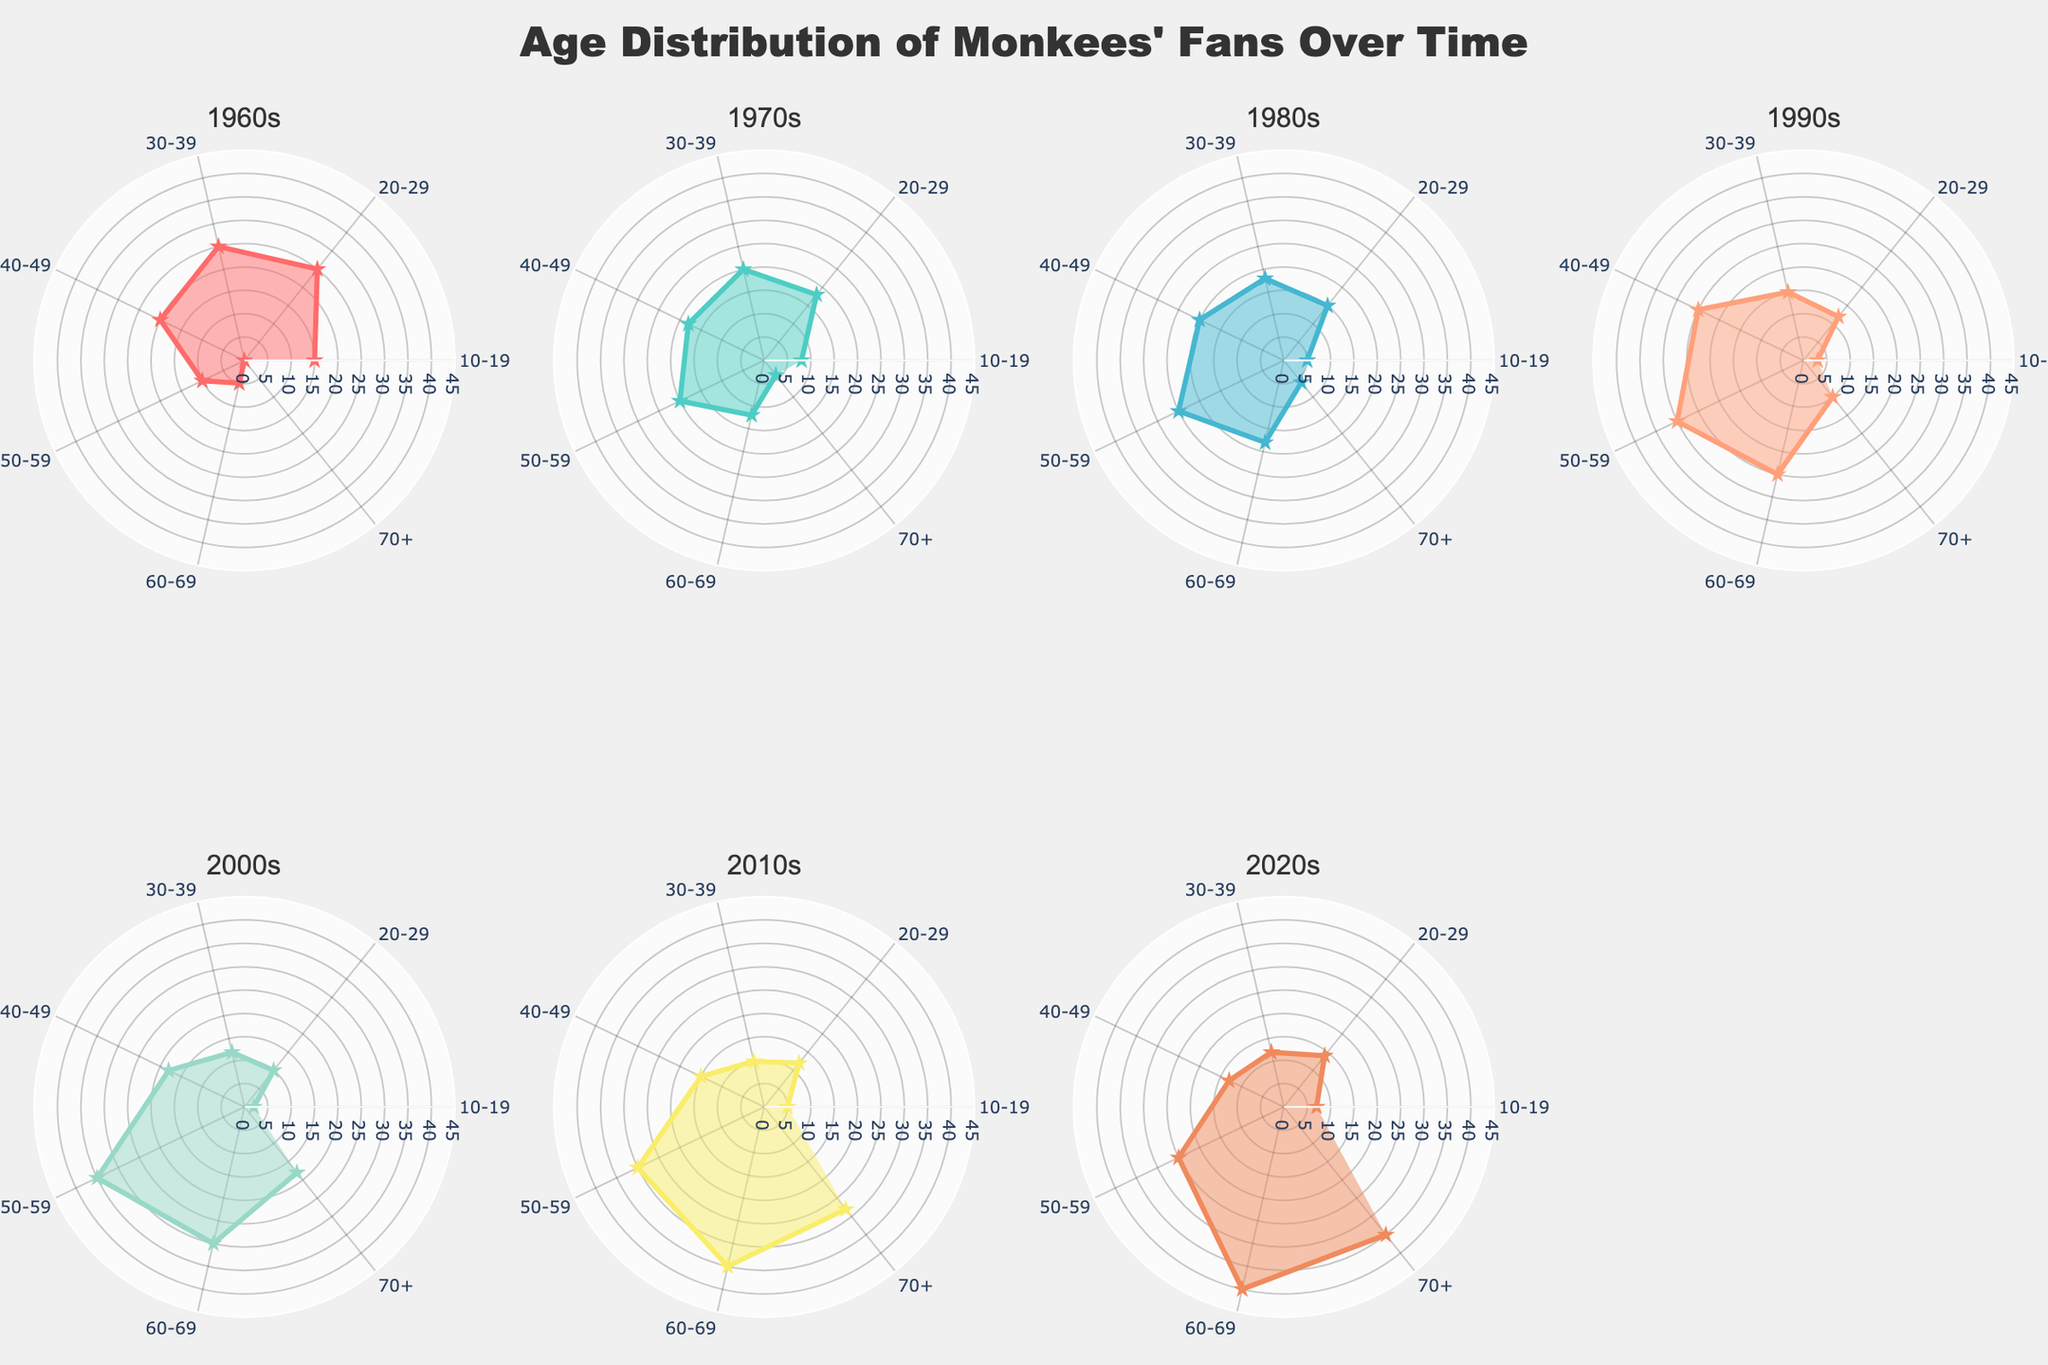What is the title of the figure? The title of the figure is typically found at the top and is prominently displayed to describe the overall content. In this case, it is clearly marked in the figure itself.
Answer: Age Distribution of Monkees' Fans Over Time What is the range of values on the radial axis? Observing the radial axis of the radar charts, the range extends from the minimum to the maximum value indicated. Here, it is visibly marked to show the range.
Answer: 0 to 45 Which age group had the highest percentage of fans in the 2020s? To find this, look at the radar plot for the 2020s and observe which age group corresponds to the longest radius. The measurements show that the age group with the highest value is near the edge of the plot.
Answer: 60-69 Which decade had the largest percentage of fans in the 50-59 age group? Locate the radial line corresponding to the 50-59 age group in each subplot and compare the lengths. The longest one indicates the highest percentage.
Answer: 2000s In the 1960s, how did the percentage of fans in the 10-19 age group compare to those in the 50-59 age group? Check the lengths of the radial lines for the 10-19 and 50-59 age groups in the 1960s subplot. Comparing these lengths will give a direct answer.
Answer: 10-19 had a higher percentage How did the percentage of fans aged 70+ change from the 1960s to the 2020s? Observe the radial line for the 70+ age group in the 1960s and 2020s plots. Note the values and calculate the difference.
Answer: Increased by 35 percentage points Which age group consistently grew in percentage from the 1960s to the 2020s? Look at the trend of each age group's radial line across all decades' subplots. Check for a consistent increase in length from the 1960s to the 2020s.
Answer: 60-69 In which decade did the percentage of fans aged 20-29 drop the most compared to the previous decade? Calculate the difference in the percentage of 20-29 age group fans between consecutive decades. The largest negative difference indicates the biggest drop.
Answer: 1970s Which age group saw a decline in percentage in the 1990s compared to the 1980s? Compare the radial lines for the 1980s and 1990s subplots across all age groups and identify which group's line got shorter from the 1980s to the 1990s.
Answer: 30-39 